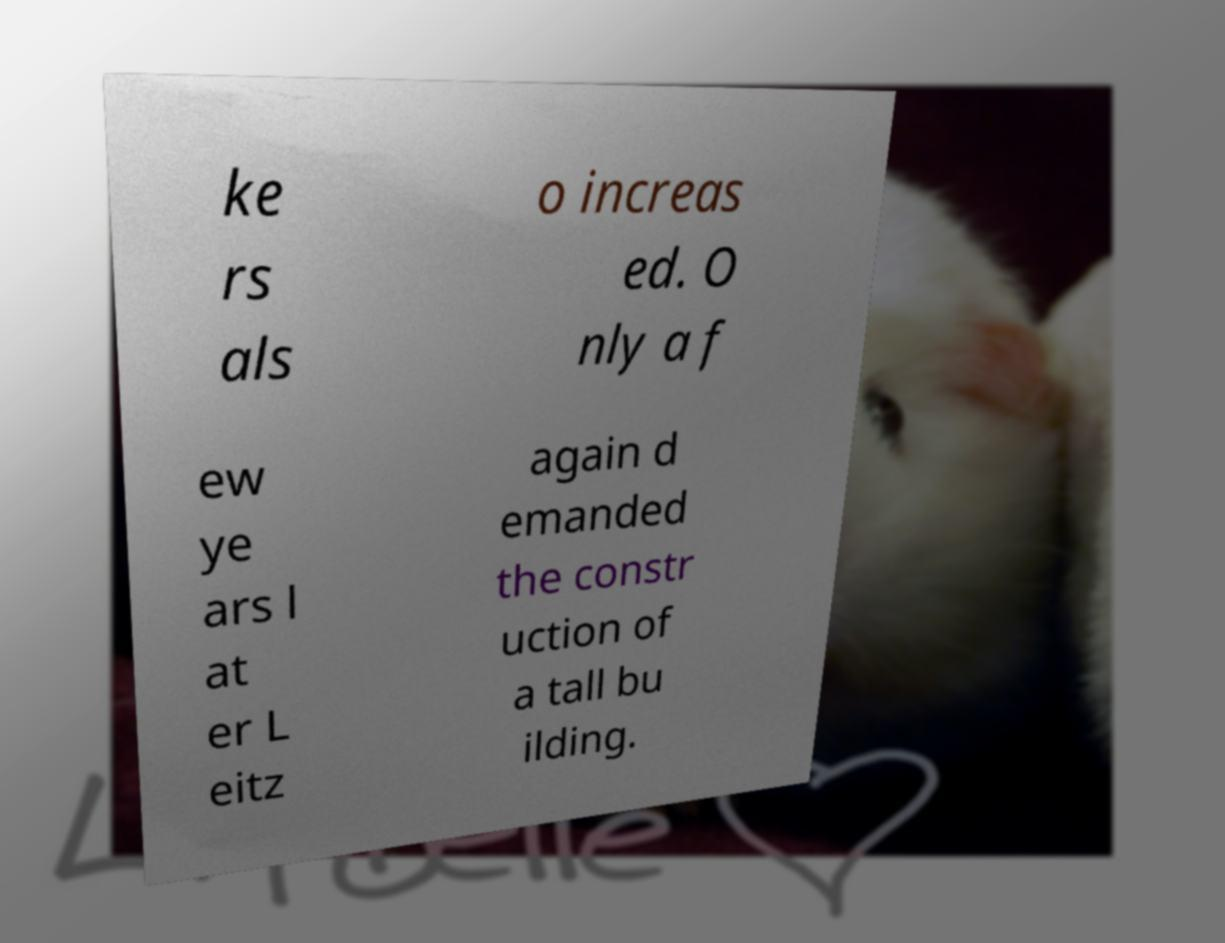Can you accurately transcribe the text from the provided image for me? ke rs als o increas ed. O nly a f ew ye ars l at er L eitz again d emanded the constr uction of a tall bu ilding. 